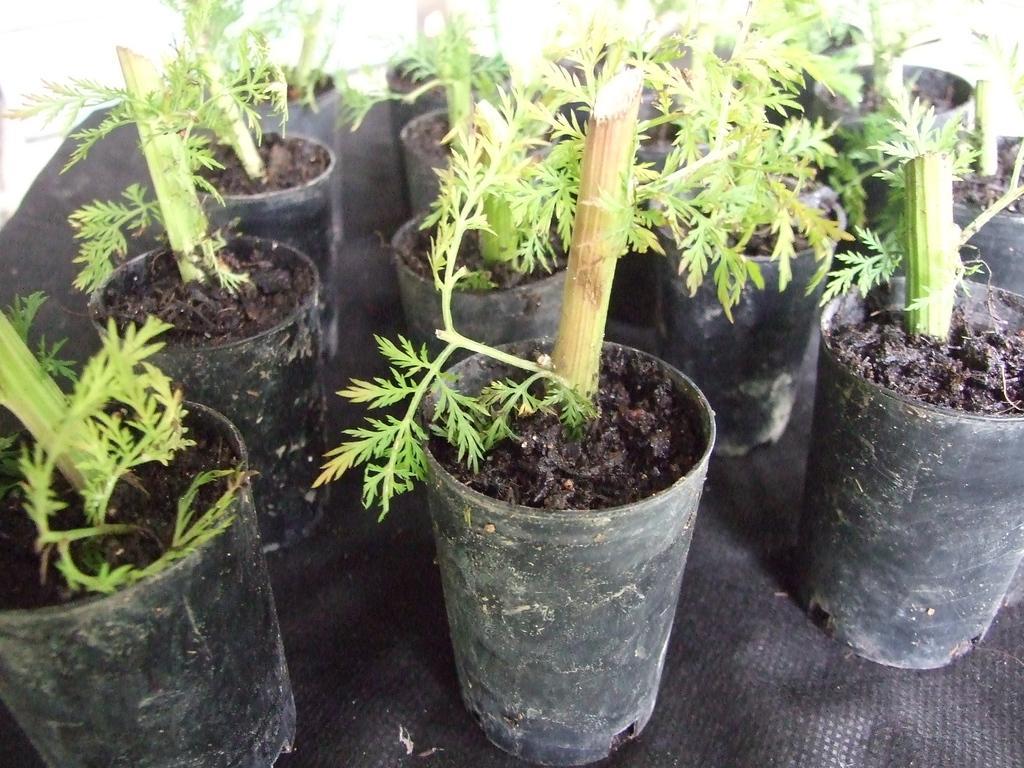How would you summarize this image in a sentence or two? In this image we can see so many potted plants. 